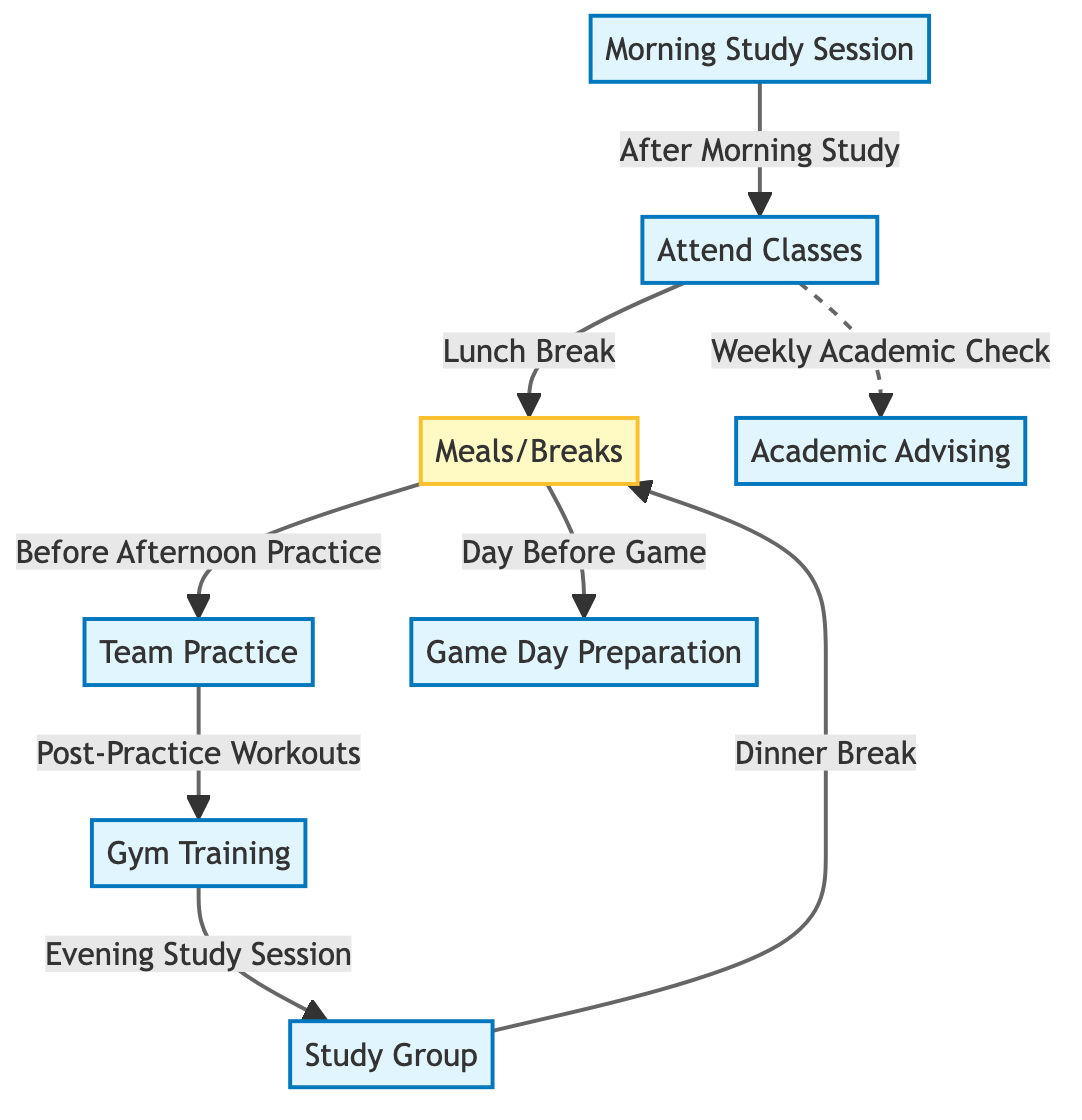What is the first activity listed in the diagram? The diagram starts with the node labeled "Morning Study Session". This is the first activity as indicated by its position in the top tier of the flowchart.
Answer: Morning Study Session How many main activities are shown in the diagram? To determine the number of main activities, we can count the nodes labeled with the activity class. The activities listed are: Morning Study Session, Team Practice, Attend Classes, Gym Training, Study Group, Game Day Preparation, and Academic Advising, totaling seven activities.
Answer: 7 Which activity directly follows the "Team Practice"? The diagram indicates that "Gym Training" follows "Team Practice", as shown by the directed arrow leading from Team Practice to Gym Training.
Answer: Gym Training What is the purpose of the "Meals/Breaks" node? The "Meals/Breaks" node appears several times in the diagram, serving as a transition between various activities. It specifically precedes "Team Practice", follows "Attend Classes", and follows "Study Group". This indicates it is a restorative break between more intense activities.
Answer: Transition between activities Which activity is scheduled the day before a game? The diagram specifies "Game Day Preparation" as the activity scheduled for the day before a game, indicated by the arrow pointing to it from "Meals/Breaks".
Answer: Game Day Preparation How does "Academic Advising" relate to "Attend Classes"? The relationship is represented by a dashed line between "Attend Classes" and the "Academic Advising" node. This suggests that attending classes leads to a weekly academic check, which may be related to Academic Advising.
Answer: Weekly Academic Check After which activity does the "Evening Study Session" occur? The diagram shows that "Evening Study Session" occurs after "Gym Training", as indicated by the directional arrow connecting the two nodes sequentially.
Answer: Gym Training What is a key difference between the "Meals/Breaks" and "Game Day Preparation" activities? "Meals/Breaks" is a restorative period that occurs multiple times in the schedule, while "Game Day Preparation" is a specific preparatory activity that happens the day before a game, indicating a more focused purpose.
Answer: Restorative vs Specific Preparation 